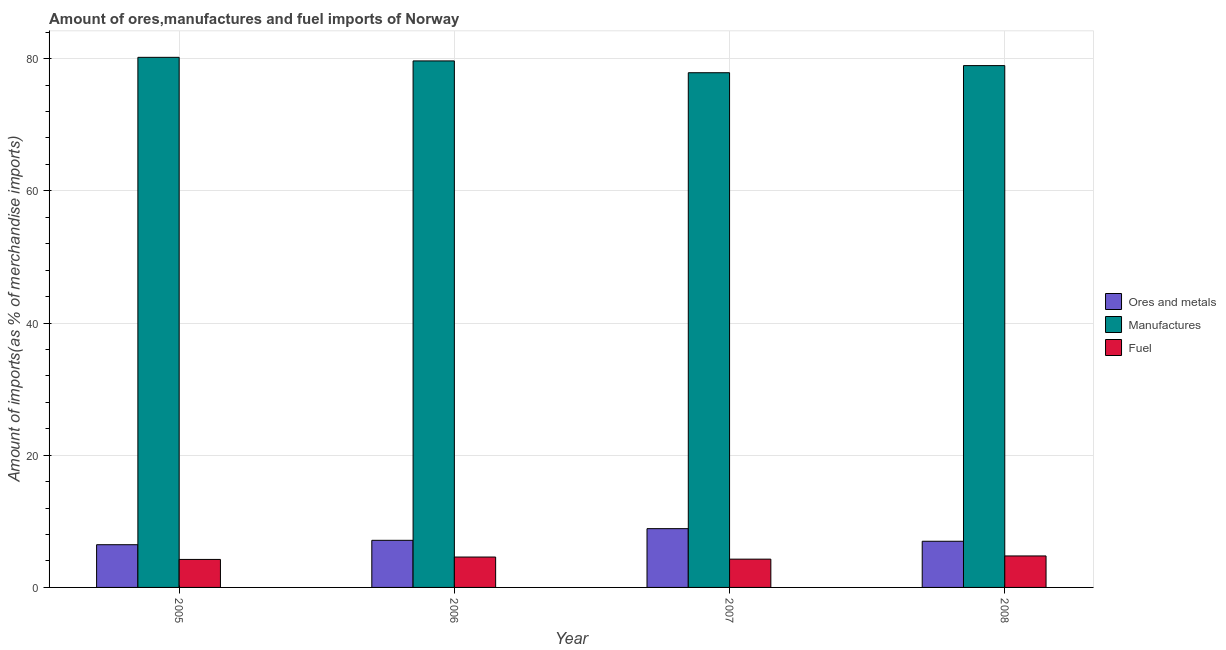How many groups of bars are there?
Give a very brief answer. 4. Are the number of bars on each tick of the X-axis equal?
Offer a very short reply. Yes. How many bars are there on the 3rd tick from the left?
Give a very brief answer. 3. What is the label of the 3rd group of bars from the left?
Ensure brevity in your answer.  2007. What is the percentage of ores and metals imports in 2006?
Ensure brevity in your answer.  7.13. Across all years, what is the maximum percentage of fuel imports?
Your response must be concise. 4.76. Across all years, what is the minimum percentage of fuel imports?
Give a very brief answer. 4.24. In which year was the percentage of fuel imports minimum?
Make the answer very short. 2005. What is the total percentage of fuel imports in the graph?
Ensure brevity in your answer.  17.88. What is the difference between the percentage of fuel imports in 2005 and that in 2007?
Give a very brief answer. -0.04. What is the difference between the percentage of ores and metals imports in 2006 and the percentage of manufactures imports in 2005?
Ensure brevity in your answer.  0.66. What is the average percentage of ores and metals imports per year?
Your answer should be very brief. 7.37. What is the ratio of the percentage of fuel imports in 2007 to that in 2008?
Keep it short and to the point. 0.9. Is the percentage of ores and metals imports in 2005 less than that in 2006?
Provide a short and direct response. Yes. What is the difference between the highest and the second highest percentage of manufactures imports?
Offer a very short reply. 0.54. What is the difference between the highest and the lowest percentage of manufactures imports?
Give a very brief answer. 2.33. In how many years, is the percentage of fuel imports greater than the average percentage of fuel imports taken over all years?
Offer a very short reply. 2. What does the 1st bar from the left in 2005 represents?
Keep it short and to the point. Ores and metals. What does the 1st bar from the right in 2007 represents?
Ensure brevity in your answer.  Fuel. How many bars are there?
Offer a terse response. 12. How many years are there in the graph?
Provide a short and direct response. 4. What is the difference between two consecutive major ticks on the Y-axis?
Provide a succinct answer. 20. Where does the legend appear in the graph?
Give a very brief answer. Center right. How many legend labels are there?
Your answer should be very brief. 3. How are the legend labels stacked?
Provide a succinct answer. Vertical. What is the title of the graph?
Offer a very short reply. Amount of ores,manufactures and fuel imports of Norway. Does "Primary" appear as one of the legend labels in the graph?
Make the answer very short. No. What is the label or title of the X-axis?
Give a very brief answer. Year. What is the label or title of the Y-axis?
Your answer should be compact. Amount of imports(as % of merchandise imports). What is the Amount of imports(as % of merchandise imports) of Ores and metals in 2005?
Ensure brevity in your answer.  6.46. What is the Amount of imports(as % of merchandise imports) in Manufactures in 2005?
Your answer should be compact. 80.21. What is the Amount of imports(as % of merchandise imports) of Fuel in 2005?
Your answer should be very brief. 4.24. What is the Amount of imports(as % of merchandise imports) of Ores and metals in 2006?
Provide a short and direct response. 7.13. What is the Amount of imports(as % of merchandise imports) in Manufactures in 2006?
Keep it short and to the point. 79.66. What is the Amount of imports(as % of merchandise imports) of Fuel in 2006?
Keep it short and to the point. 4.6. What is the Amount of imports(as % of merchandise imports) of Ores and metals in 2007?
Give a very brief answer. 8.89. What is the Amount of imports(as % of merchandise imports) in Manufactures in 2007?
Your response must be concise. 77.88. What is the Amount of imports(as % of merchandise imports) in Fuel in 2007?
Give a very brief answer. 4.28. What is the Amount of imports(as % of merchandise imports) in Ores and metals in 2008?
Your response must be concise. 6.99. What is the Amount of imports(as % of merchandise imports) of Manufactures in 2008?
Offer a very short reply. 78.95. What is the Amount of imports(as % of merchandise imports) in Fuel in 2008?
Ensure brevity in your answer.  4.76. Across all years, what is the maximum Amount of imports(as % of merchandise imports) of Ores and metals?
Offer a terse response. 8.89. Across all years, what is the maximum Amount of imports(as % of merchandise imports) in Manufactures?
Your answer should be compact. 80.21. Across all years, what is the maximum Amount of imports(as % of merchandise imports) in Fuel?
Your answer should be very brief. 4.76. Across all years, what is the minimum Amount of imports(as % of merchandise imports) in Ores and metals?
Your answer should be compact. 6.46. Across all years, what is the minimum Amount of imports(as % of merchandise imports) of Manufactures?
Your response must be concise. 77.88. Across all years, what is the minimum Amount of imports(as % of merchandise imports) of Fuel?
Offer a terse response. 4.24. What is the total Amount of imports(as % of merchandise imports) in Ores and metals in the graph?
Your answer should be very brief. 29.47. What is the total Amount of imports(as % of merchandise imports) in Manufactures in the graph?
Keep it short and to the point. 316.7. What is the total Amount of imports(as % of merchandise imports) in Fuel in the graph?
Offer a terse response. 17.88. What is the difference between the Amount of imports(as % of merchandise imports) in Ores and metals in 2005 and that in 2006?
Give a very brief answer. -0.66. What is the difference between the Amount of imports(as % of merchandise imports) in Manufactures in 2005 and that in 2006?
Give a very brief answer. 0.54. What is the difference between the Amount of imports(as % of merchandise imports) in Fuel in 2005 and that in 2006?
Offer a terse response. -0.36. What is the difference between the Amount of imports(as % of merchandise imports) of Ores and metals in 2005 and that in 2007?
Keep it short and to the point. -2.43. What is the difference between the Amount of imports(as % of merchandise imports) in Manufactures in 2005 and that in 2007?
Offer a terse response. 2.33. What is the difference between the Amount of imports(as % of merchandise imports) in Fuel in 2005 and that in 2007?
Your response must be concise. -0.04. What is the difference between the Amount of imports(as % of merchandise imports) of Ores and metals in 2005 and that in 2008?
Your response must be concise. -0.52. What is the difference between the Amount of imports(as % of merchandise imports) in Manufactures in 2005 and that in 2008?
Provide a succinct answer. 1.25. What is the difference between the Amount of imports(as % of merchandise imports) in Fuel in 2005 and that in 2008?
Give a very brief answer. -0.53. What is the difference between the Amount of imports(as % of merchandise imports) of Ores and metals in 2006 and that in 2007?
Offer a terse response. -1.77. What is the difference between the Amount of imports(as % of merchandise imports) in Manufactures in 2006 and that in 2007?
Your answer should be compact. 1.79. What is the difference between the Amount of imports(as % of merchandise imports) of Fuel in 2006 and that in 2007?
Provide a succinct answer. 0.32. What is the difference between the Amount of imports(as % of merchandise imports) of Ores and metals in 2006 and that in 2008?
Provide a short and direct response. 0.14. What is the difference between the Amount of imports(as % of merchandise imports) in Manufactures in 2006 and that in 2008?
Your answer should be very brief. 0.71. What is the difference between the Amount of imports(as % of merchandise imports) in Fuel in 2006 and that in 2008?
Keep it short and to the point. -0.16. What is the difference between the Amount of imports(as % of merchandise imports) in Ores and metals in 2007 and that in 2008?
Offer a very short reply. 1.91. What is the difference between the Amount of imports(as % of merchandise imports) of Manufactures in 2007 and that in 2008?
Offer a terse response. -1.08. What is the difference between the Amount of imports(as % of merchandise imports) in Fuel in 2007 and that in 2008?
Offer a very short reply. -0.48. What is the difference between the Amount of imports(as % of merchandise imports) in Ores and metals in 2005 and the Amount of imports(as % of merchandise imports) in Manufactures in 2006?
Make the answer very short. -73.2. What is the difference between the Amount of imports(as % of merchandise imports) in Ores and metals in 2005 and the Amount of imports(as % of merchandise imports) in Fuel in 2006?
Give a very brief answer. 1.87. What is the difference between the Amount of imports(as % of merchandise imports) of Manufactures in 2005 and the Amount of imports(as % of merchandise imports) of Fuel in 2006?
Ensure brevity in your answer.  75.61. What is the difference between the Amount of imports(as % of merchandise imports) of Ores and metals in 2005 and the Amount of imports(as % of merchandise imports) of Manufactures in 2007?
Provide a succinct answer. -71.41. What is the difference between the Amount of imports(as % of merchandise imports) in Ores and metals in 2005 and the Amount of imports(as % of merchandise imports) in Fuel in 2007?
Your answer should be very brief. 2.18. What is the difference between the Amount of imports(as % of merchandise imports) of Manufactures in 2005 and the Amount of imports(as % of merchandise imports) of Fuel in 2007?
Provide a succinct answer. 75.93. What is the difference between the Amount of imports(as % of merchandise imports) in Ores and metals in 2005 and the Amount of imports(as % of merchandise imports) in Manufactures in 2008?
Give a very brief answer. -72.49. What is the difference between the Amount of imports(as % of merchandise imports) in Ores and metals in 2005 and the Amount of imports(as % of merchandise imports) in Fuel in 2008?
Your answer should be compact. 1.7. What is the difference between the Amount of imports(as % of merchandise imports) of Manufactures in 2005 and the Amount of imports(as % of merchandise imports) of Fuel in 2008?
Your answer should be very brief. 75.44. What is the difference between the Amount of imports(as % of merchandise imports) of Ores and metals in 2006 and the Amount of imports(as % of merchandise imports) of Manufactures in 2007?
Ensure brevity in your answer.  -70.75. What is the difference between the Amount of imports(as % of merchandise imports) of Ores and metals in 2006 and the Amount of imports(as % of merchandise imports) of Fuel in 2007?
Make the answer very short. 2.85. What is the difference between the Amount of imports(as % of merchandise imports) of Manufactures in 2006 and the Amount of imports(as % of merchandise imports) of Fuel in 2007?
Your answer should be very brief. 75.38. What is the difference between the Amount of imports(as % of merchandise imports) of Ores and metals in 2006 and the Amount of imports(as % of merchandise imports) of Manufactures in 2008?
Make the answer very short. -71.83. What is the difference between the Amount of imports(as % of merchandise imports) of Ores and metals in 2006 and the Amount of imports(as % of merchandise imports) of Fuel in 2008?
Keep it short and to the point. 2.36. What is the difference between the Amount of imports(as % of merchandise imports) of Manufactures in 2006 and the Amount of imports(as % of merchandise imports) of Fuel in 2008?
Your response must be concise. 74.9. What is the difference between the Amount of imports(as % of merchandise imports) of Ores and metals in 2007 and the Amount of imports(as % of merchandise imports) of Manufactures in 2008?
Keep it short and to the point. -70.06. What is the difference between the Amount of imports(as % of merchandise imports) in Ores and metals in 2007 and the Amount of imports(as % of merchandise imports) in Fuel in 2008?
Offer a terse response. 4.13. What is the difference between the Amount of imports(as % of merchandise imports) of Manufactures in 2007 and the Amount of imports(as % of merchandise imports) of Fuel in 2008?
Offer a terse response. 73.11. What is the average Amount of imports(as % of merchandise imports) in Ores and metals per year?
Your answer should be compact. 7.37. What is the average Amount of imports(as % of merchandise imports) in Manufactures per year?
Provide a short and direct response. 79.17. What is the average Amount of imports(as % of merchandise imports) of Fuel per year?
Offer a terse response. 4.47. In the year 2005, what is the difference between the Amount of imports(as % of merchandise imports) in Ores and metals and Amount of imports(as % of merchandise imports) in Manufactures?
Your answer should be compact. -73.74. In the year 2005, what is the difference between the Amount of imports(as % of merchandise imports) in Ores and metals and Amount of imports(as % of merchandise imports) in Fuel?
Make the answer very short. 2.23. In the year 2005, what is the difference between the Amount of imports(as % of merchandise imports) in Manufactures and Amount of imports(as % of merchandise imports) in Fuel?
Give a very brief answer. 75.97. In the year 2006, what is the difference between the Amount of imports(as % of merchandise imports) in Ores and metals and Amount of imports(as % of merchandise imports) in Manufactures?
Ensure brevity in your answer.  -72.54. In the year 2006, what is the difference between the Amount of imports(as % of merchandise imports) of Ores and metals and Amount of imports(as % of merchandise imports) of Fuel?
Your response must be concise. 2.53. In the year 2006, what is the difference between the Amount of imports(as % of merchandise imports) in Manufactures and Amount of imports(as % of merchandise imports) in Fuel?
Ensure brevity in your answer.  75.06. In the year 2007, what is the difference between the Amount of imports(as % of merchandise imports) in Ores and metals and Amount of imports(as % of merchandise imports) in Manufactures?
Provide a succinct answer. -68.98. In the year 2007, what is the difference between the Amount of imports(as % of merchandise imports) in Ores and metals and Amount of imports(as % of merchandise imports) in Fuel?
Your answer should be compact. 4.61. In the year 2007, what is the difference between the Amount of imports(as % of merchandise imports) of Manufactures and Amount of imports(as % of merchandise imports) of Fuel?
Provide a short and direct response. 73.6. In the year 2008, what is the difference between the Amount of imports(as % of merchandise imports) of Ores and metals and Amount of imports(as % of merchandise imports) of Manufactures?
Provide a succinct answer. -71.97. In the year 2008, what is the difference between the Amount of imports(as % of merchandise imports) in Ores and metals and Amount of imports(as % of merchandise imports) in Fuel?
Give a very brief answer. 2.22. In the year 2008, what is the difference between the Amount of imports(as % of merchandise imports) in Manufactures and Amount of imports(as % of merchandise imports) in Fuel?
Your answer should be compact. 74.19. What is the ratio of the Amount of imports(as % of merchandise imports) in Ores and metals in 2005 to that in 2006?
Offer a very short reply. 0.91. What is the ratio of the Amount of imports(as % of merchandise imports) of Manufactures in 2005 to that in 2006?
Provide a short and direct response. 1.01. What is the ratio of the Amount of imports(as % of merchandise imports) of Fuel in 2005 to that in 2006?
Give a very brief answer. 0.92. What is the ratio of the Amount of imports(as % of merchandise imports) of Ores and metals in 2005 to that in 2007?
Your response must be concise. 0.73. What is the ratio of the Amount of imports(as % of merchandise imports) in Manufactures in 2005 to that in 2007?
Give a very brief answer. 1.03. What is the ratio of the Amount of imports(as % of merchandise imports) of Ores and metals in 2005 to that in 2008?
Provide a short and direct response. 0.93. What is the ratio of the Amount of imports(as % of merchandise imports) of Manufactures in 2005 to that in 2008?
Your response must be concise. 1.02. What is the ratio of the Amount of imports(as % of merchandise imports) in Fuel in 2005 to that in 2008?
Keep it short and to the point. 0.89. What is the ratio of the Amount of imports(as % of merchandise imports) in Ores and metals in 2006 to that in 2007?
Your answer should be very brief. 0.8. What is the ratio of the Amount of imports(as % of merchandise imports) of Manufactures in 2006 to that in 2007?
Make the answer very short. 1.02. What is the ratio of the Amount of imports(as % of merchandise imports) in Fuel in 2006 to that in 2007?
Ensure brevity in your answer.  1.07. What is the ratio of the Amount of imports(as % of merchandise imports) of Ores and metals in 2006 to that in 2008?
Provide a short and direct response. 1.02. What is the ratio of the Amount of imports(as % of merchandise imports) of Manufactures in 2006 to that in 2008?
Your response must be concise. 1.01. What is the ratio of the Amount of imports(as % of merchandise imports) of Fuel in 2006 to that in 2008?
Offer a very short reply. 0.97. What is the ratio of the Amount of imports(as % of merchandise imports) of Ores and metals in 2007 to that in 2008?
Your answer should be compact. 1.27. What is the ratio of the Amount of imports(as % of merchandise imports) in Manufactures in 2007 to that in 2008?
Keep it short and to the point. 0.99. What is the ratio of the Amount of imports(as % of merchandise imports) of Fuel in 2007 to that in 2008?
Your answer should be compact. 0.9. What is the difference between the highest and the second highest Amount of imports(as % of merchandise imports) in Ores and metals?
Make the answer very short. 1.77. What is the difference between the highest and the second highest Amount of imports(as % of merchandise imports) of Manufactures?
Provide a succinct answer. 0.54. What is the difference between the highest and the second highest Amount of imports(as % of merchandise imports) in Fuel?
Your response must be concise. 0.16. What is the difference between the highest and the lowest Amount of imports(as % of merchandise imports) in Ores and metals?
Make the answer very short. 2.43. What is the difference between the highest and the lowest Amount of imports(as % of merchandise imports) of Manufactures?
Make the answer very short. 2.33. What is the difference between the highest and the lowest Amount of imports(as % of merchandise imports) of Fuel?
Offer a terse response. 0.53. 